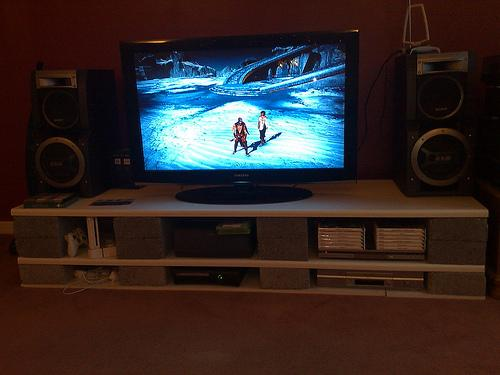Mention the number and types of speakers in the image, along with their position with respect to the television. There are two speakers, one next to the TV on the left and another on the right, both black and grey. Explain the setting where the image was taken and what the room seems to be used for. The image is taken in an entertainment room with a television, speakers, and video game consoles used for playing games and watching movies. How many video game consoles are in the image, and what are their types and colors? There are two video game consoles: a black Xbox 360 and a white Nintendo console. Identify the main object in the image and describe its color and size. The main object in the image is a flat screen television with a black frame, measuring 272 pixels in width and 272 pixels in height. Count and describe the CDs in the cubbies of the TV stand. There are nine CDs in cubbies, with variations in height, width, and positioning, contributing to the organized yet varied display of media. Analyze the image from an object interaction perspective by identifying the connection between the various objects. The objects in the image, including the television, speakers, video game consoles, DVD cases, video games, controllers, and wires, are all connected through the purpose of providing a multimedia entertainment experience. Describe the cases containing the DVDs and their location in the image. There are a couple of DVD cases, a case of DVDs under the TV, and a case with a bunch of DVDs, all located at the bottom of the image. What is the condition of the room, and how does it affect the overall sentiment of the image? The room appears to be in the dark, which gives a more immersive gaming or movie-watching experience and a mysterious atmosphere. What type of flooring does the room have, and what is its color? The room has a light brown carpet flooring. Provide a comprehensive description of the image focusing on the video games and their cases. The image features Xbox 360 video games in green cases, a couple of DVD cases, a case of DVDs under the TV, and video games on a shelf, all related to playing and organizing titles for entertainment. 